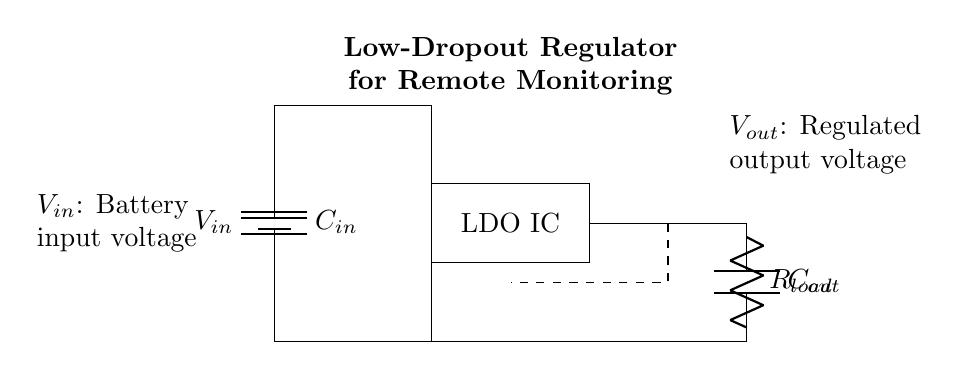What is the input voltage for this circuit? The input voltage is denoted as V_in, which is connected to the battery symbol in the diagram.
Answer: V_in What type of capacitor is C_in? The component labeled C_in is a capacitor, as indicated by the symbol in the diagram, and typically this type of capacitor is used for filtering.
Answer: Capacitor What is the function of the LDO IC in this circuit? The LDO IC regulates the voltage output, ensuring a stable output voltage from the varying input battery voltage.
Answer: Regulate voltage What can you infer about the relationship between V_out and R_load? V_out is the regulated output voltage, which will decrease as R_load increases if the load resistance is significant enough to affect the current. This is based on Ohm's Law.
Answer: Inversely related How does the feedback connection impact the circuit operation? The feedback connection helps the regulator maintain a constant output voltage by adjusting the current flow based on the voltage sensed at V_out, ensuring stability and regulation.
Answer: Maintains stability What does C_out do in the circuit? C_out, as the output capacitor, smooths the output voltage, minimizing voltage ripple and improving performance during load changes.
Answer: Smooths output What component allows for low dropout voltage in this regulator? The LDO IC is specifically designed to have a low dropout voltage, meaning it can maintain regulation even when the input voltage is only slightly higher than the output voltage.
Answer: LDO IC 